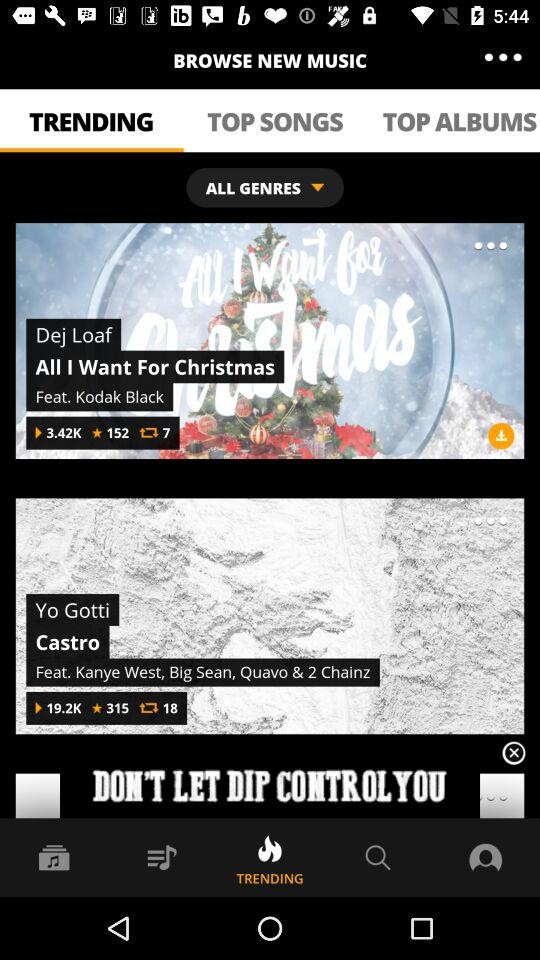Who is the artist of the song "All I Want For Christmas"? The artists behind the song "All I Want For Christmas" are Dej Loaf and Kodak Black. 